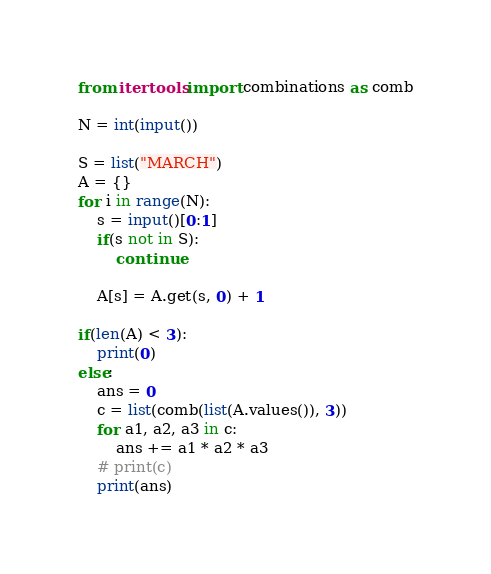Convert code to text. <code><loc_0><loc_0><loc_500><loc_500><_Python_>from itertools import combinations as comb

N = int(input())

S = list("MARCH")
A = {}
for i in range(N):
    s = input()[0:1]
    if(s not in S):
        continue

    A[s] = A.get(s, 0) + 1

if(len(A) < 3):
    print(0)
else:
    ans = 0
    c = list(comb(list(A.values()), 3))
    for a1, a2, a3 in c:
        ans += a1 * a2 * a3
    # print(c)
    print(ans)</code> 